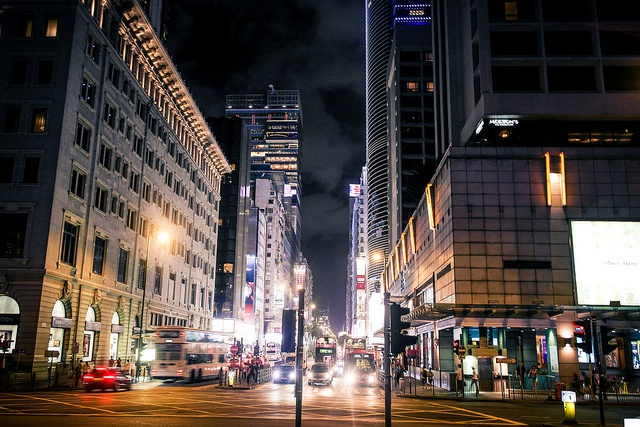Describe the objects in this image and their specific colors. I can see bus in black, gray, and lightgray tones, car in black, maroon, red, and brown tones, traffic light in black and gray tones, traffic light in black, gray, white, and navy tones, and traffic light in black, navy, purple, blue, and darkblue tones in this image. 